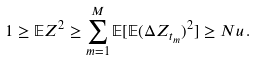Convert formula to latex. <formula><loc_0><loc_0><loc_500><loc_500>1 \geq \mathbb { E } Z ^ { 2 } \geq \sum _ { m = 1 } ^ { M } \mathbb { E } [ \mathbb { E } ( \Delta Z _ { t _ { m } } ) ^ { 2 } ] \geq N u \, .</formula> 